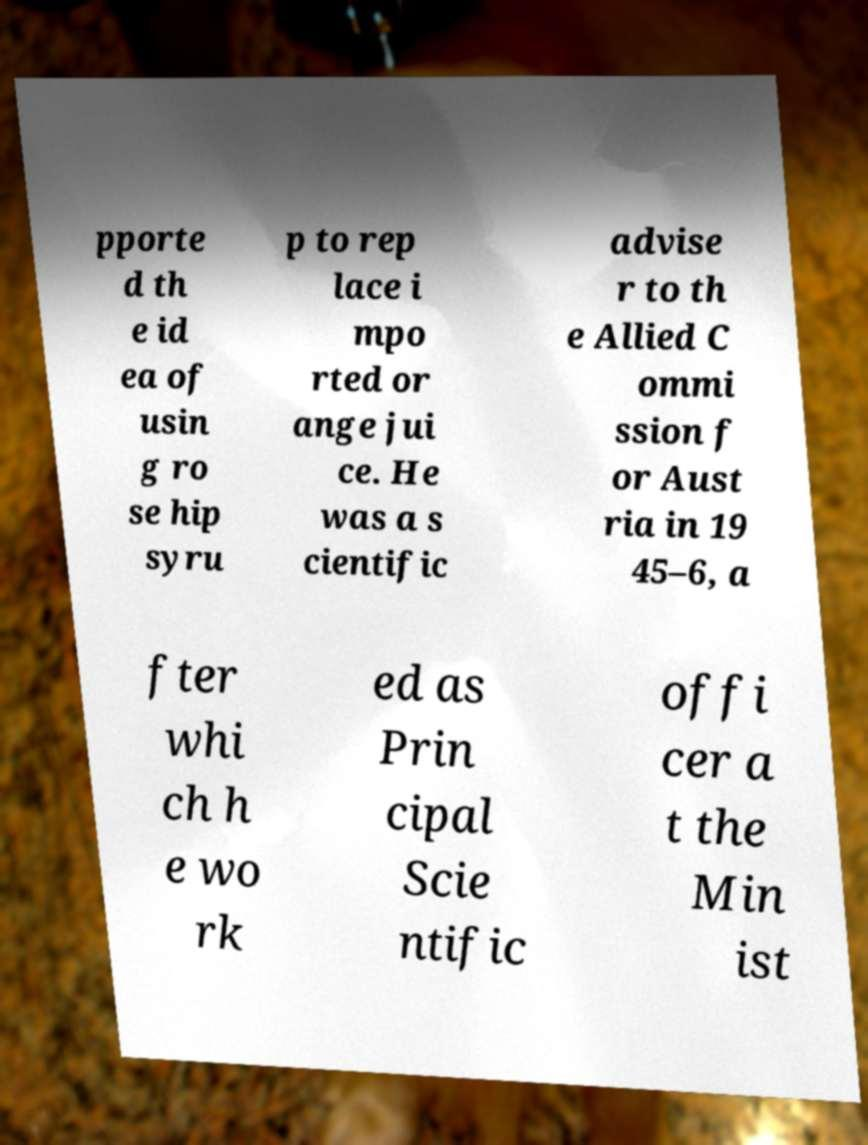What messages or text are displayed in this image? I need them in a readable, typed format. pporte d th e id ea of usin g ro se hip syru p to rep lace i mpo rted or ange jui ce. He was a s cientific advise r to th e Allied C ommi ssion f or Aust ria in 19 45–6, a fter whi ch h e wo rk ed as Prin cipal Scie ntific offi cer a t the Min ist 